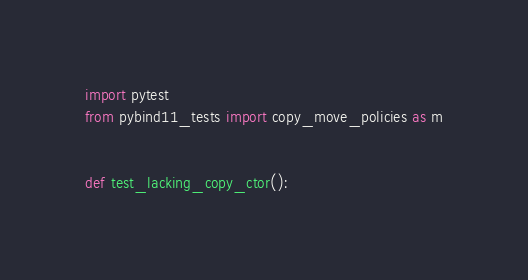Convert code to text. <code><loc_0><loc_0><loc_500><loc_500><_Python_>import pytest
from pybind11_tests import copy_move_policies as m


def test_lacking_copy_ctor():</code> 